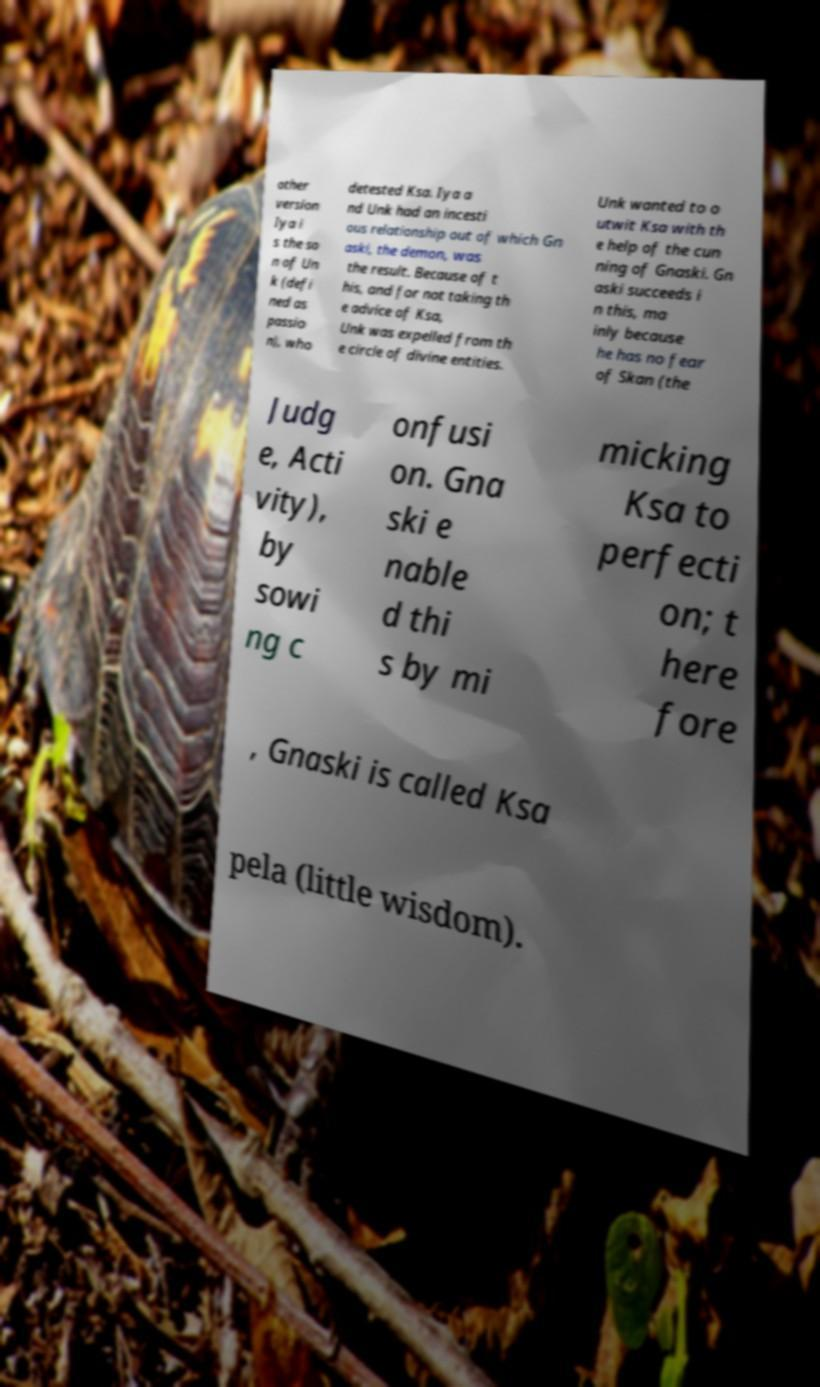Can you read and provide the text displayed in the image?This photo seems to have some interesting text. Can you extract and type it out for me? other version Iya i s the so n of Un k (defi ned as passio n), who detested Ksa. Iya a nd Unk had an incesti ous relationship out of which Gn aski, the demon, was the result. Because of t his, and for not taking th e advice of Ksa, Unk was expelled from th e circle of divine entities. Unk wanted to o utwit Ksa with th e help of the cun ning of Gnaski. Gn aski succeeds i n this, ma inly because he has no fear of Skan (the Judg e, Acti vity), by sowi ng c onfusi on. Gna ski e nable d thi s by mi micking Ksa to perfecti on; t here fore , Gnaski is called Ksa pela (little wisdom). 